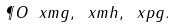Convert formula to latex. <formula><loc_0><loc_0><loc_500><loc_500>\P O { \ x m { g } , \ x m { h } , \ x p { g } } .</formula> 